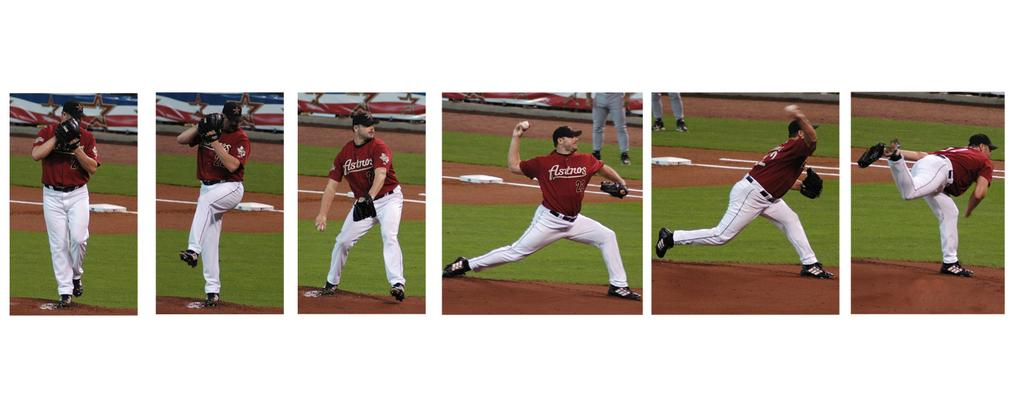Provide a one-sentence caption for the provided image. An Astros player in a red jersey can be seen throwing a pitch. 